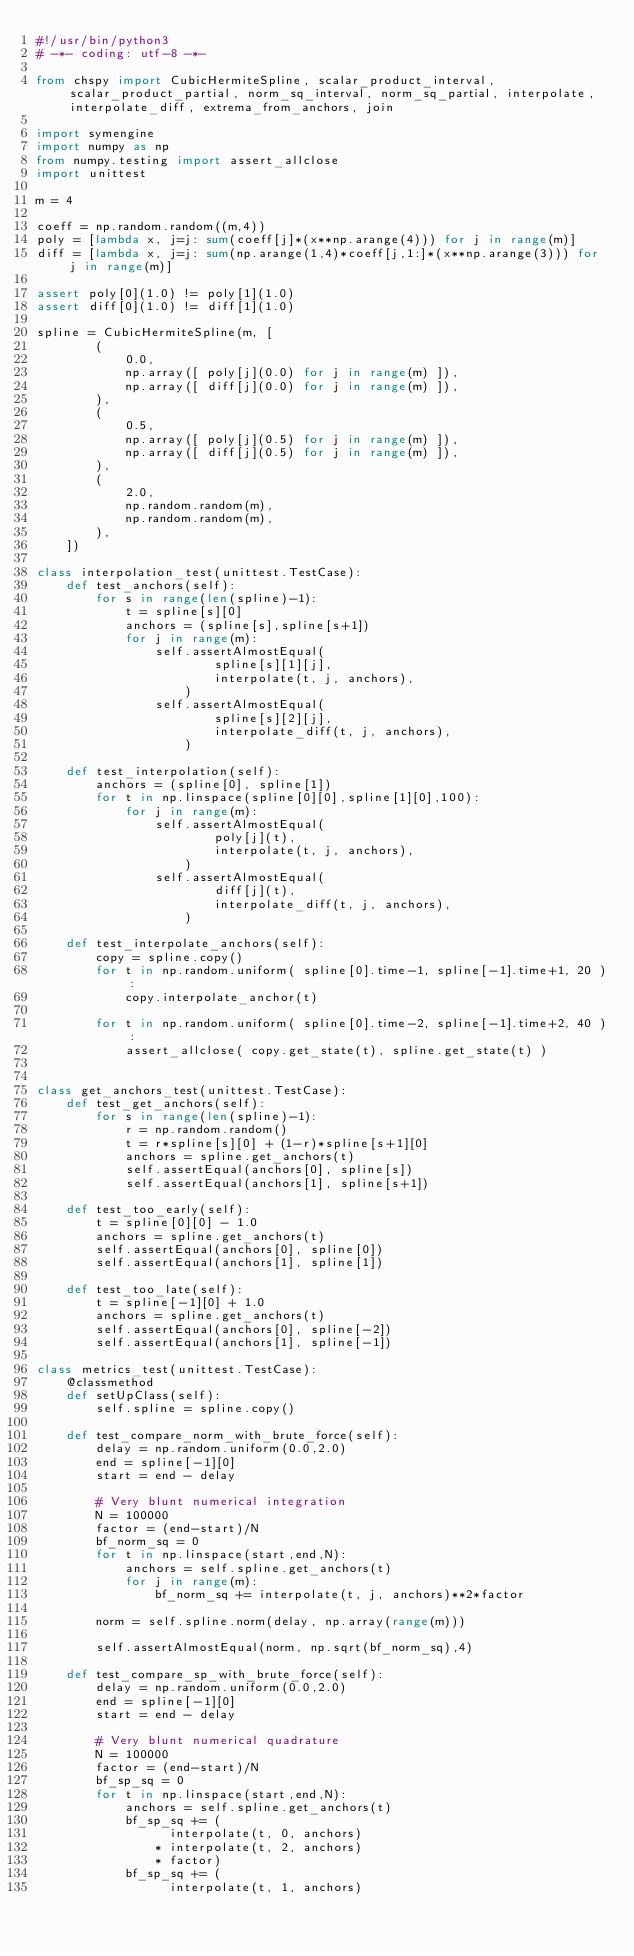<code> <loc_0><loc_0><loc_500><loc_500><_Python_>#!/usr/bin/python3
# -*- coding: utf-8 -*-

from chspy import CubicHermiteSpline, scalar_product_interval, scalar_product_partial, norm_sq_interval, norm_sq_partial, interpolate, interpolate_diff, extrema_from_anchors, join

import symengine
import numpy as np
from numpy.testing import assert_allclose
import unittest

m = 4

coeff = np.random.random((m,4))
poly = [lambda x, j=j: sum(coeff[j]*(x**np.arange(4))) for j in range(m)]
diff = [lambda x, j=j: sum(np.arange(1,4)*coeff[j,1:]*(x**np.arange(3))) for j in range(m)]

assert poly[0](1.0) != poly[1](1.0)
assert diff[0](1.0) != diff[1](1.0)

spline = CubicHermiteSpline(m, [
		(
			0.0,
			np.array([ poly[j](0.0) for j in range(m) ]),
			np.array([ diff[j](0.0) for j in range(m) ]),
		),
		(
			0.5,
			np.array([ poly[j](0.5) for j in range(m) ]),
			np.array([ diff[j](0.5) for j in range(m) ]),
		),
		(
			2.0,
			np.random.random(m),
			np.random.random(m),
		),
	])

class interpolation_test(unittest.TestCase):
	def test_anchors(self):
		for s in range(len(spline)-1):
			t = spline[s][0]
			anchors = (spline[s],spline[s+1])
			for j in range(m):
				self.assertAlmostEqual(
						spline[s][1][j],
						interpolate(t, j, anchors),
					)
				self.assertAlmostEqual(
						spline[s][2][j],
						interpolate_diff(t, j, anchors),
					)
	
	def test_interpolation(self):
		anchors = (spline[0], spline[1])
		for t in np.linspace(spline[0][0],spline[1][0],100):
			for j in range(m):
				self.assertAlmostEqual(
						poly[j](t),
						interpolate(t, j, anchors),
					)
				self.assertAlmostEqual(
						diff[j](t),
						interpolate_diff(t, j, anchors),
					)
	
	def test_interpolate_anchors(self):
		copy = spline.copy()
		for t in np.random.uniform( spline[0].time-1, spline[-1].time+1, 20 ):
			copy.interpolate_anchor(t)
		
		for t in np.random.uniform( spline[0].time-2, spline[-1].time+2, 40 ):
			assert_allclose( copy.get_state(t), spline.get_state(t) )


class get_anchors_test(unittest.TestCase):
	def test_get_anchors(self):
		for s in range(len(spline)-1):
			r = np.random.random()
			t = r*spline[s][0] + (1-r)*spline[s+1][0]
			anchors = spline.get_anchors(t)
			self.assertEqual(anchors[0], spline[s])
			self.assertEqual(anchors[1], spline[s+1])
	
	def test_too_early(self):
		t = spline[0][0] - 1.0
		anchors = spline.get_anchors(t)
		self.assertEqual(anchors[0], spline[0])
		self.assertEqual(anchors[1], spline[1])

	def test_too_late(self):
		t = spline[-1][0] + 1.0
		anchors = spline.get_anchors(t)
		self.assertEqual(anchors[0], spline[-2])
		self.assertEqual(anchors[1], spline[-1])

class metrics_test(unittest.TestCase):
	@classmethod
	def setUpClass(self):
		self.spline = spline.copy()
	
	def test_compare_norm_with_brute_force(self):
		delay = np.random.uniform(0.0,2.0)
		end = spline[-1][0]
		start = end - delay
		
		# Very blunt numerical integration
		N = 100000
		factor = (end-start)/N
		bf_norm_sq = 0
		for t in np.linspace(start,end,N):
			anchors = self.spline.get_anchors(t)
			for j in range(m):
				bf_norm_sq += interpolate(t, j, anchors)**2*factor
		
		norm = self.spline.norm(delay, np.array(range(m)))
		
		self.assertAlmostEqual(norm, np.sqrt(bf_norm_sq),4)
		
	def test_compare_sp_with_brute_force(self):
		delay = np.random.uniform(0.0,2.0)
		end = spline[-1][0]
		start = end - delay
		
		# Very blunt numerical quadrature
		N = 100000
		factor = (end-start)/N
		bf_sp_sq = 0
		for t in np.linspace(start,end,N):
			anchors = self.spline.get_anchors(t)
			bf_sp_sq += (
				  interpolate(t, 0, anchors)
				* interpolate(t, 2, anchors)
				* factor)
			bf_sp_sq += (
				  interpolate(t, 1, anchors)</code> 